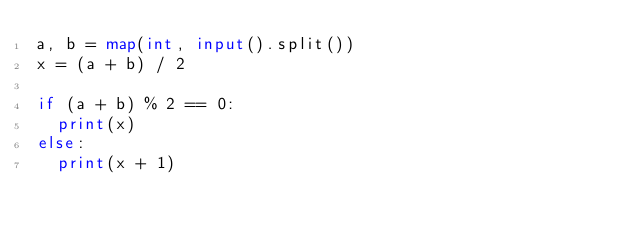Convert code to text. <code><loc_0><loc_0><loc_500><loc_500><_Python_>a, b = map(int, input().split())
x = (a + b) / 2

if (a + b) % 2 == 0:
  print(x)
else:
  print(x + 1)</code> 